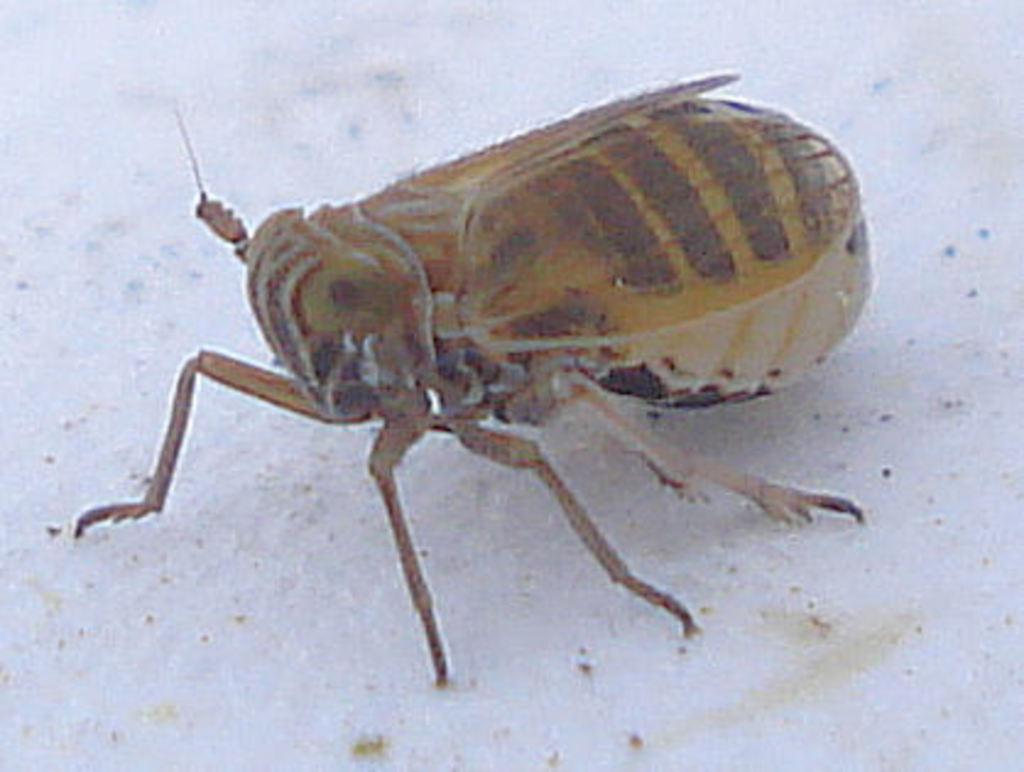What type of creature can be seen in the image? There is an insect in the image. What part of the insect is emitting light in the image? There is no indication in the image that the insect is emitting light or has any light-emitting parts. 